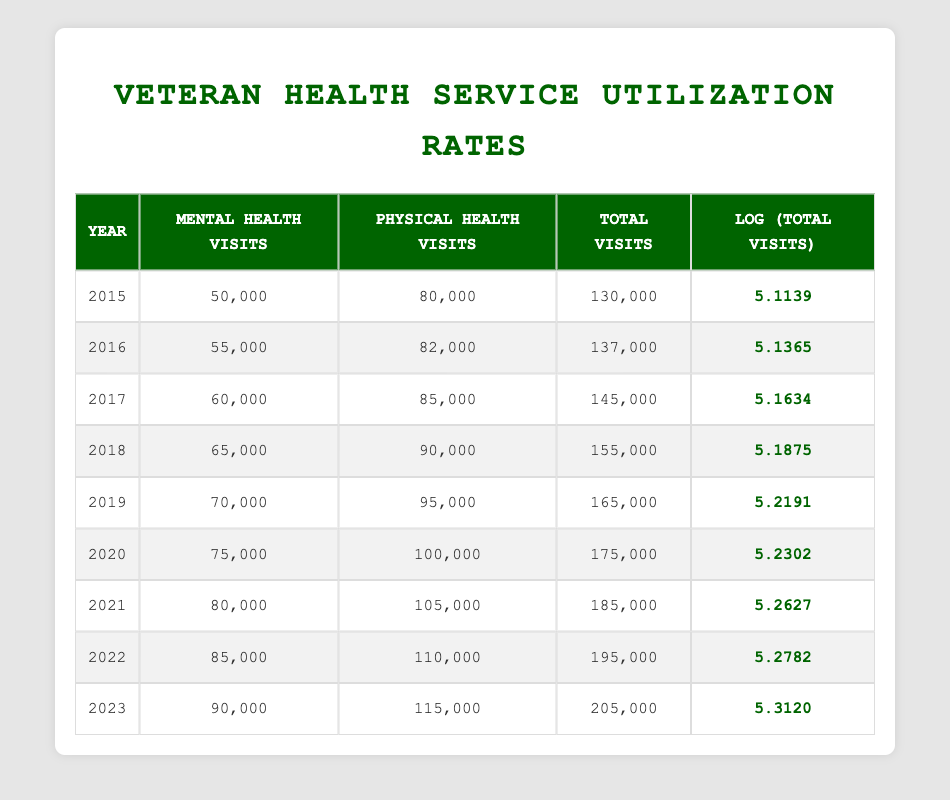What was the total number of health service visits in 2019? In the table, I look at the row for the year 2019. The total visits listed there is 165,000.
Answer: 165,000 What is the logarithmic value of total visits for 2021? I check the row for the year 2021 in the table. The log total visits value is shown as 5.2627.
Answer: 5.2627 What year had the highest number of mental health visits? I scan through the mental health visits column for all years. The highest number is 90,000, which occurred in 2023.
Answer: 2023 What was the increase in total visits from 2015 to 2023? I find the total visits for 2015 (130,000) and for 2023 (205,000). The increase is calculated by subtracting 130,000 from 205,000, giving an increase of 75,000.
Answer: 75,000 Did the physical health visits in 2022 exceed those in 2020? I look at the physical health visits for both 2022 (110,000) and 2020 (100,000). Since 110,000 is greater than 100,000, the answer is yes.
Answer: Yes What is the average number of mental health visits from 2015 to 2023? I sum the mental health visits from all those years: (50,000 + 55,000 + 60,000 + 65,000 + 70,000 + 75,000 + 80,000 + 85,000 + 90,000) =  665,000. There are 9 years, so I divide 665,000 by 9, resulting in an average of approximately 73,889.
Answer: 73,889 Which year saw the smallest increase in total visits compared to the previous year? I look at the total visits for each year and calculate the difference between each consecutive year: 2015-16 (7,000), 2016-17 (8,000), 2017-18 (10,000), 2018-19 (10,000), 2019-20 (10,000), 2020-21 (10,000), 2021-22 (10,000), and 2022-23 (10,000). The smallest increase was from 2015 to 2016, which was 7,000.
Answer: 2015 to 2016 What percentage of total visits in 2023 were mental health visits? I take the total visits for 2023 (205,000) and the mental health visits (90,000). The percentage is calculated by (90,000 / 205,000) * 100, which gives approximately 43.9%.
Answer: 43.9% 